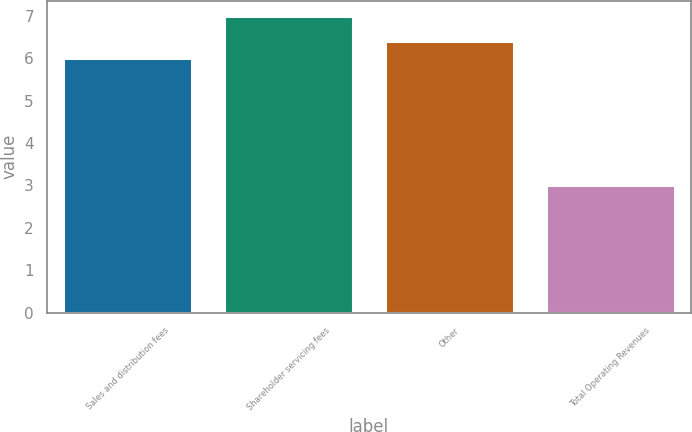Convert chart. <chart><loc_0><loc_0><loc_500><loc_500><bar_chart><fcel>Sales and distribution fees<fcel>Shareholder servicing fees<fcel>Other<fcel>Total Operating Revenues<nl><fcel>6<fcel>7<fcel>6.4<fcel>3<nl></chart> 